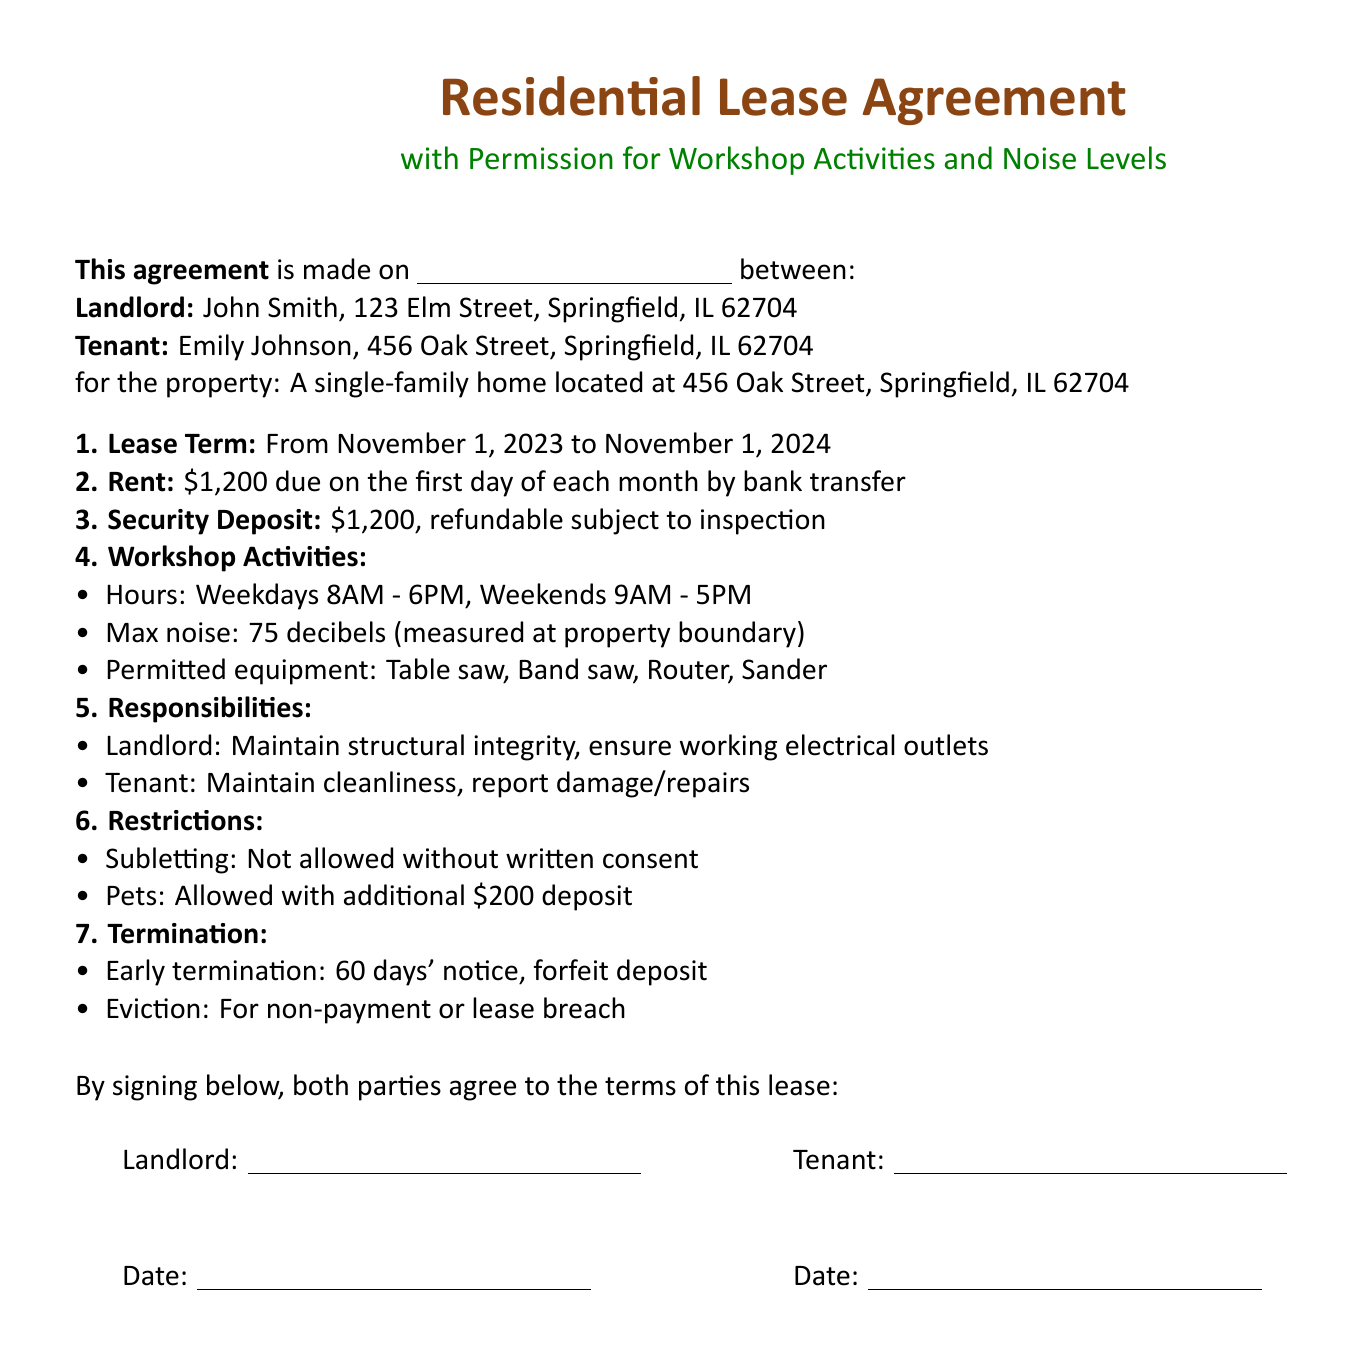What is the lease term? The lease term is stated in the document, indicating when the lease begins and ends.
Answer: From November 1, 2023 to November 1, 2024 Who is the landlord? The document specifies the landlord's name and address at the beginning of the agreement.
Answer: John Smith, 123 Elm Street, Springfield, IL 62704 What is the rent amount? The document clearly lists the monthly rent amount due from the tenant.
Answer: $1,200 What is the maximum noise level allowed? The document specifies the maximum noise level that can be produced during workshop activities.
Answer: 75 decibels What is the pet deposit amount? The document states the additional deposit required for pets.
Answer: $200 What are the workshop hours on weekends? The document mentions the specific hours permitted for workshop activities during weekends.
Answer: 9AM - 5PM What is the notice period for early termination? The document details the required notice period if the tenant wants to terminate the lease early.
Answer: 60 days Is subletting allowed? The document clearly states the policy regarding subletting the property.
Answer: Not allowed without written consent What types of equipment are permitted? The document lists the specific equipment that the tenant is allowed to use in their workshop.
Answer: Table saw, Band saw, Router, Sander 